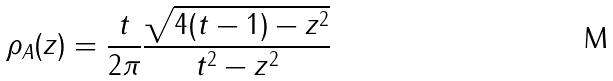<formula> <loc_0><loc_0><loc_500><loc_500>\rho _ { A } ( z ) = \frac { t } { 2 \pi } \frac { \sqrt { 4 ( t - 1 ) - z ^ { 2 } } } { t ^ { 2 } - z ^ { 2 } }</formula> 